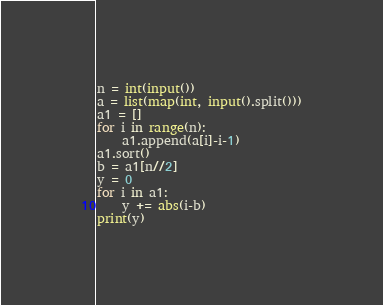<code> <loc_0><loc_0><loc_500><loc_500><_Python_>n = int(input())
a = list(map(int, input().split()))
a1 = []
for i in range(n):
    a1.append(a[i]-i-1)
a1.sort()
b = a1[n//2]
y = 0
for i in a1:
    y += abs(i-b)
print(y)</code> 